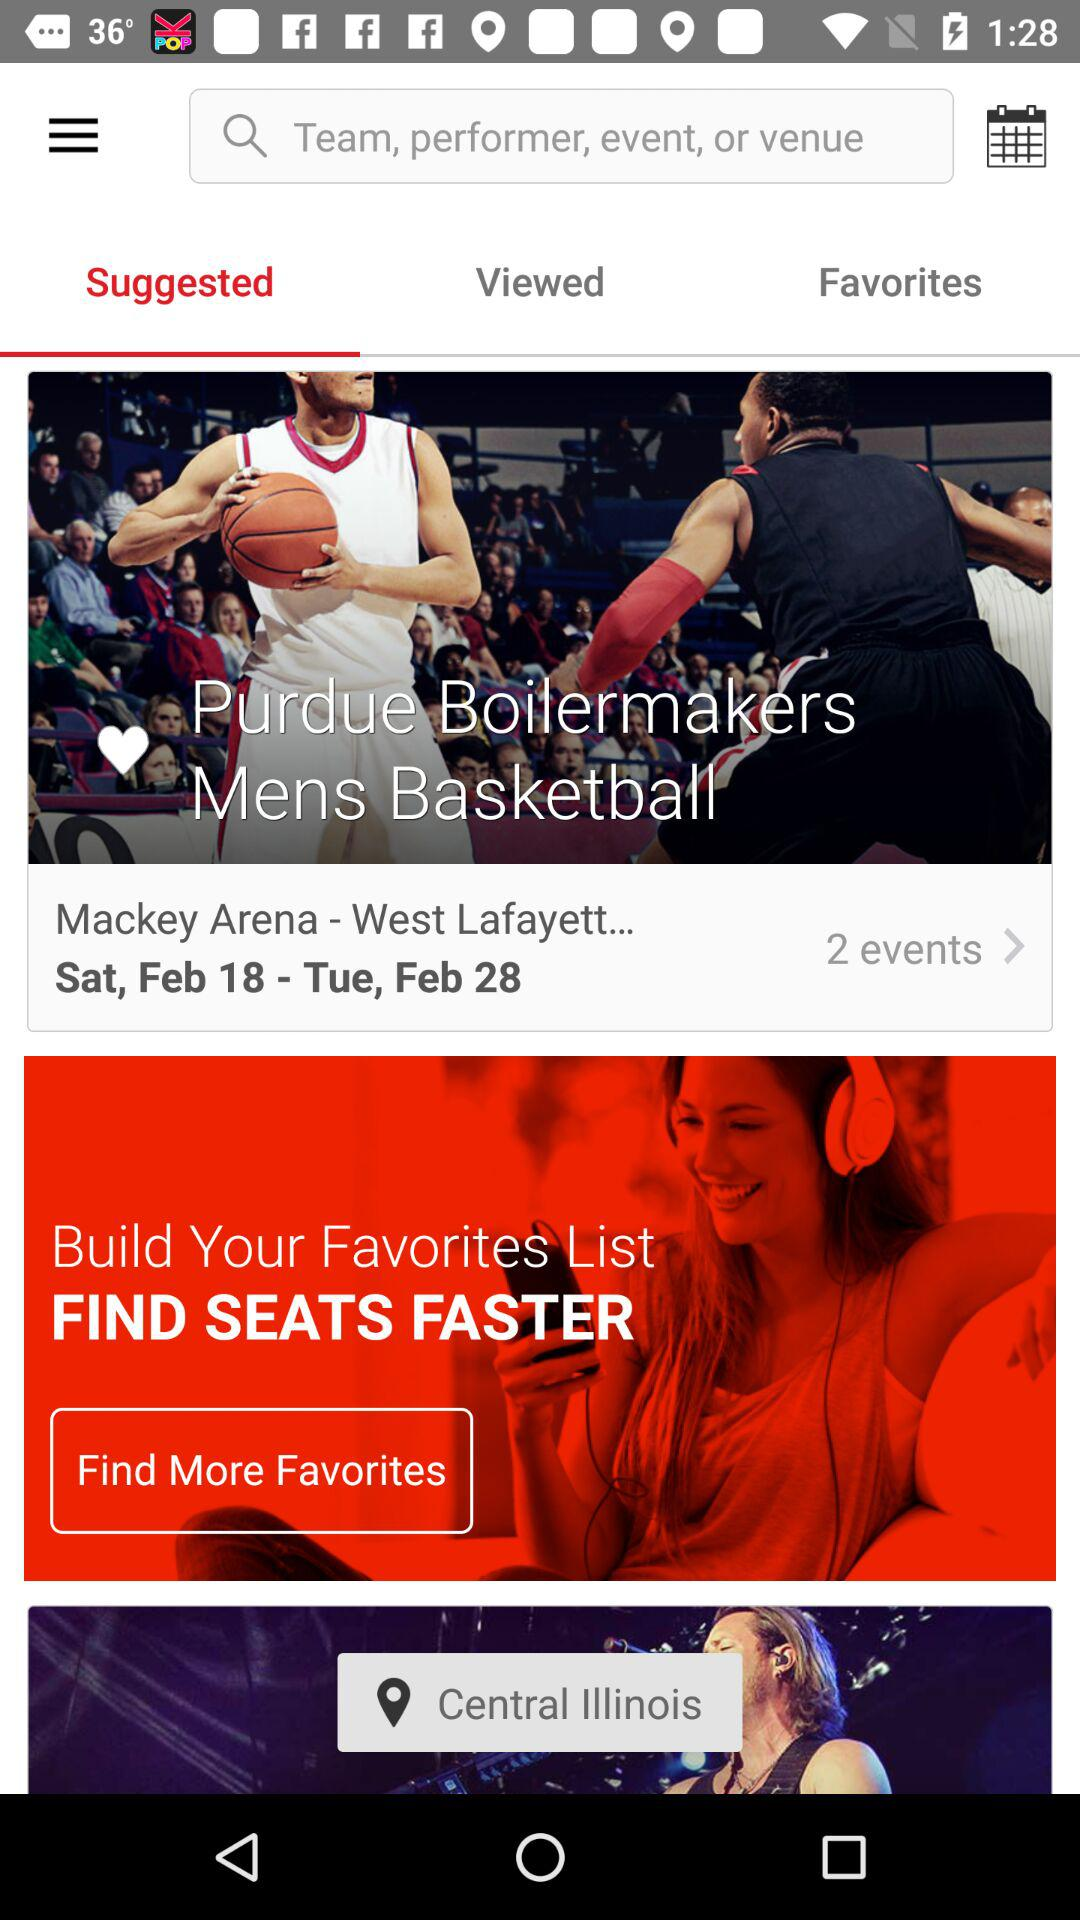Which tab is selected? The selected tab is "Suggested". 